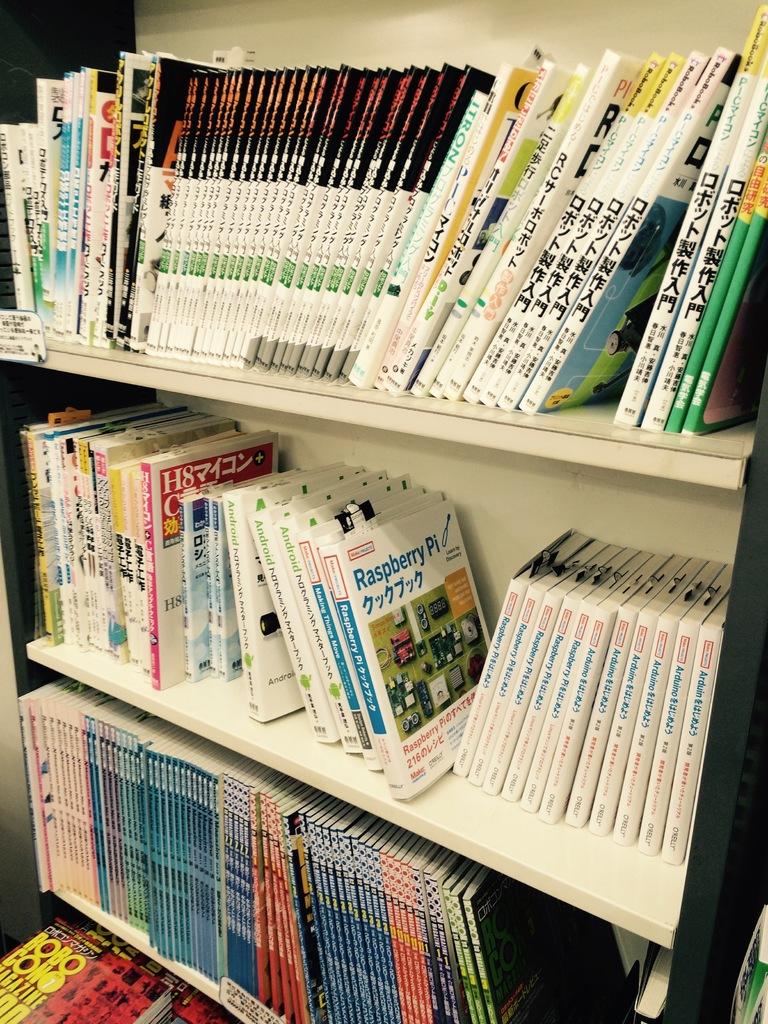What is the book on the middle shelf about?
Make the answer very short. Raspberry pi. Which language are the books on the top shelf written in?
Give a very brief answer. Chinese. 